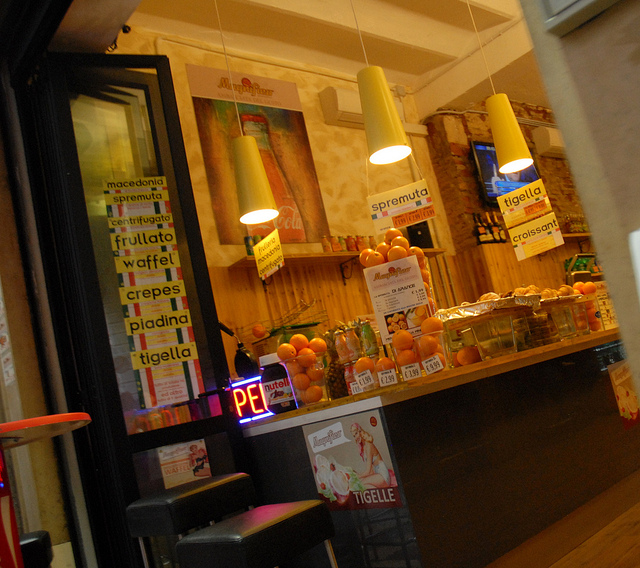Read and extract the text from this image. spremuta frullato waffel crepes Piadina tigella TIGELLE Croissant tigella PEI Spremuta 